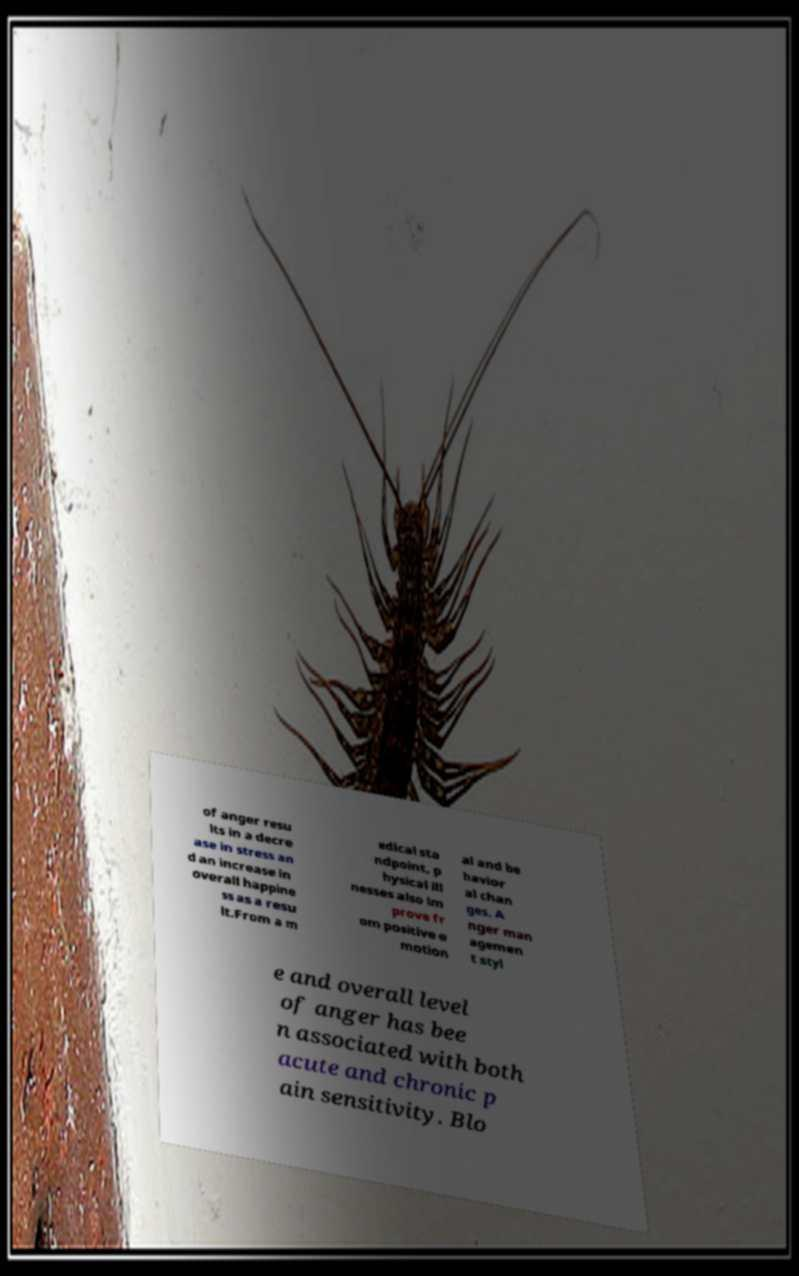Please identify and transcribe the text found in this image. of anger resu lts in a decre ase in stress an d an increase in overall happine ss as a resu lt.From a m edical sta ndpoint, p hysical ill nesses also im prove fr om positive e motion al and be havior al chan ges. A nger man agemen t styl e and overall level of anger has bee n associated with both acute and chronic p ain sensitivity. Blo 